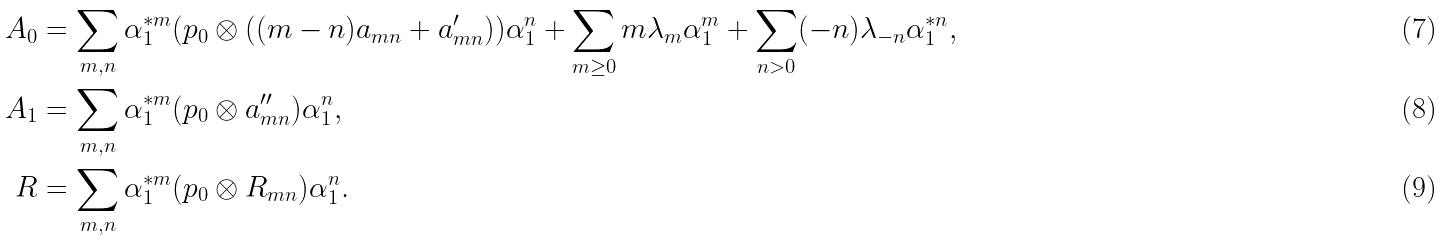<formula> <loc_0><loc_0><loc_500><loc_500>A _ { 0 } & = \sum _ { m , n } \alpha _ { 1 } ^ { * m } ( p _ { 0 } \otimes ( ( m - n ) a _ { m n } + a ^ { \prime } _ { m n } ) ) \alpha _ { 1 } ^ { n } + \sum _ { m \geq 0 } m \lambda _ { m } \alpha _ { 1 } ^ { m } + \sum _ { n > 0 } ( - n ) \lambda _ { - n } \alpha _ { 1 } ^ { * n } , \\ A _ { 1 } & = \sum _ { m , n } \alpha _ { 1 } ^ { * m } ( p _ { 0 } \otimes a ^ { \prime \prime } _ { m n } ) \alpha _ { 1 } ^ { n } , \\ R & = \sum _ { m , n } \alpha _ { 1 } ^ { * m } ( p _ { 0 } \otimes R _ { m n } ) \alpha _ { 1 } ^ { n } .</formula> 